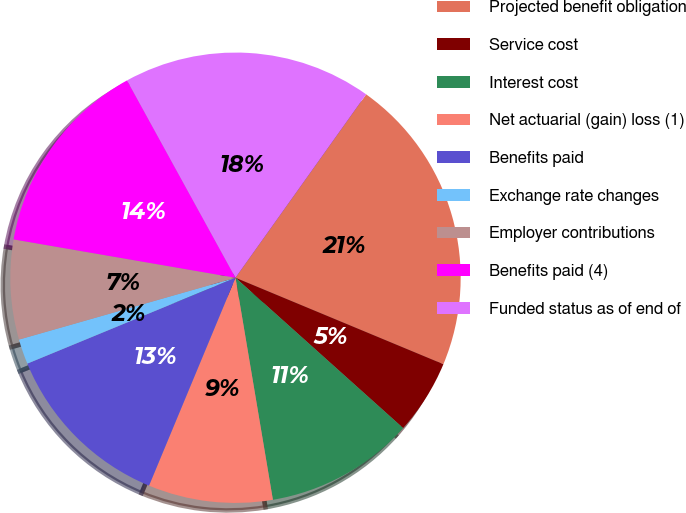<chart> <loc_0><loc_0><loc_500><loc_500><pie_chart><fcel>Projected benefit obligation<fcel>Service cost<fcel>Interest cost<fcel>Net actuarial (gain) loss (1)<fcel>Benefits paid<fcel>Exchange rate changes<fcel>Employer contributions<fcel>Benefits paid (4)<fcel>Funded status as of end of<nl><fcel>21.42%<fcel>5.36%<fcel>10.71%<fcel>8.93%<fcel>12.5%<fcel>1.8%<fcel>7.15%<fcel>14.28%<fcel>17.85%<nl></chart> 